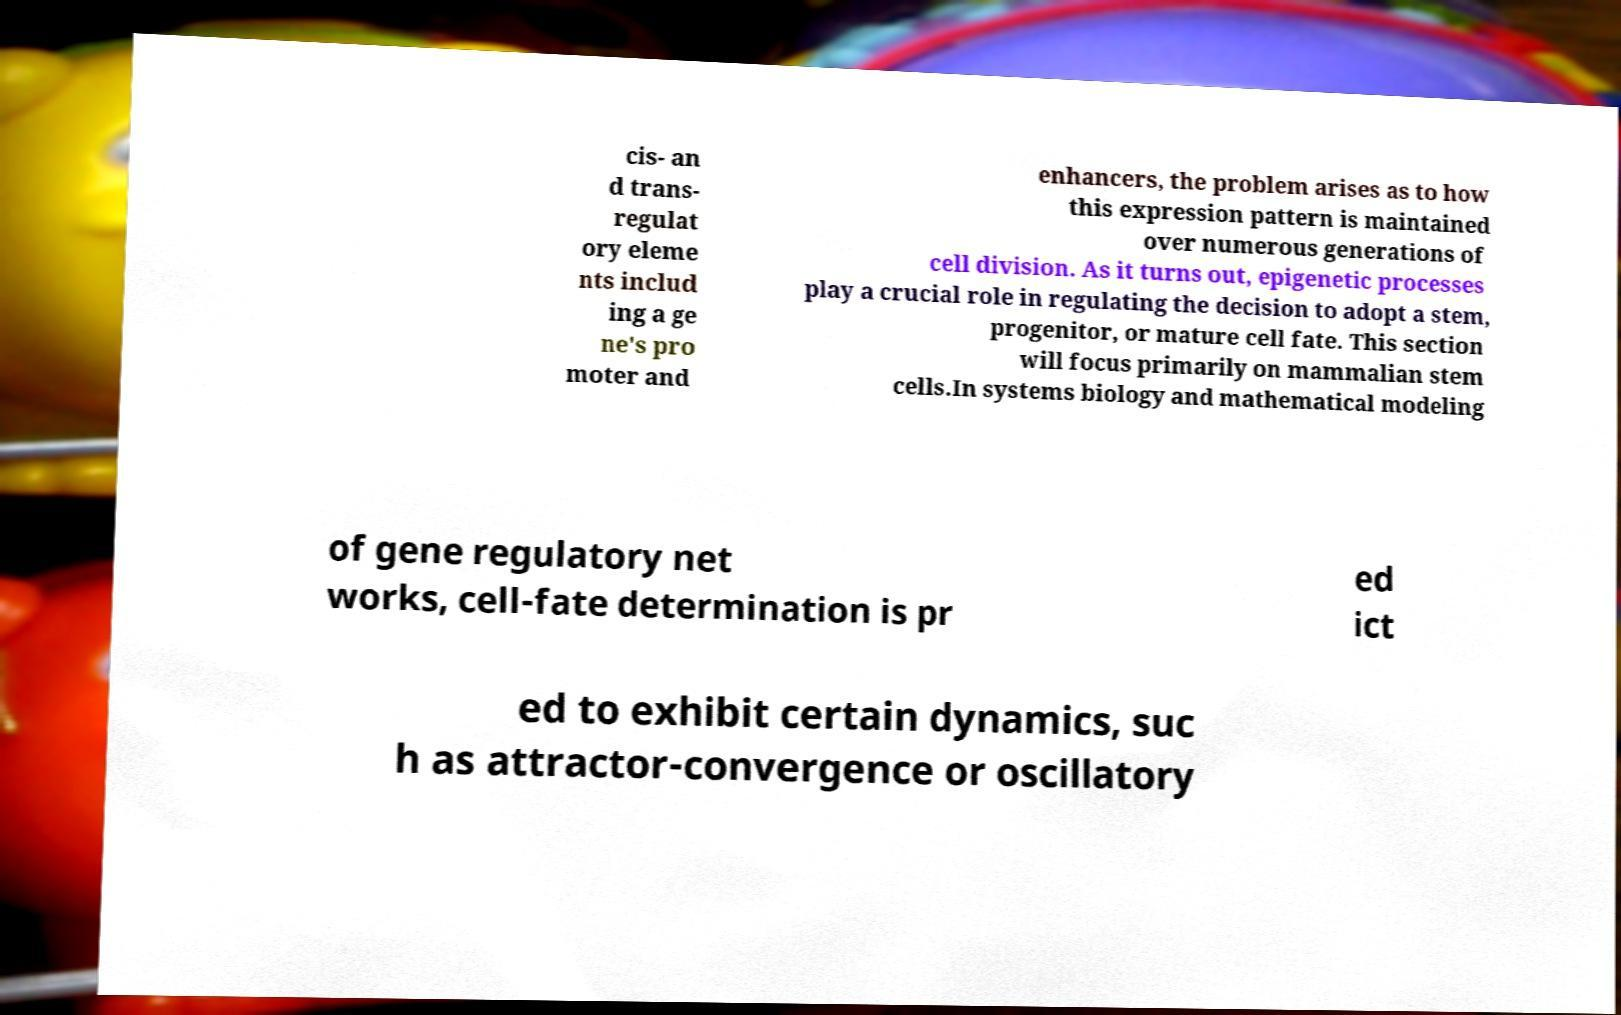There's text embedded in this image that I need extracted. Can you transcribe it verbatim? cis- an d trans- regulat ory eleme nts includ ing a ge ne's pro moter and enhancers, the problem arises as to how this expression pattern is maintained over numerous generations of cell division. As it turns out, epigenetic processes play a crucial role in regulating the decision to adopt a stem, progenitor, or mature cell fate. This section will focus primarily on mammalian stem cells.In systems biology and mathematical modeling of gene regulatory net works, cell-fate determination is pr ed ict ed to exhibit certain dynamics, suc h as attractor-convergence or oscillatory 